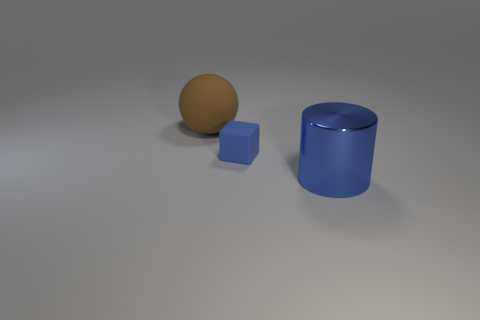Add 3 metallic cylinders. How many objects exist? 6 Subtract all blocks. How many objects are left? 2 Add 3 blue objects. How many blue objects are left? 5 Add 3 small blue blocks. How many small blue blocks exist? 4 Subtract 0 cyan cylinders. How many objects are left? 3 Subtract all small objects. Subtract all big brown rubber things. How many objects are left? 1 